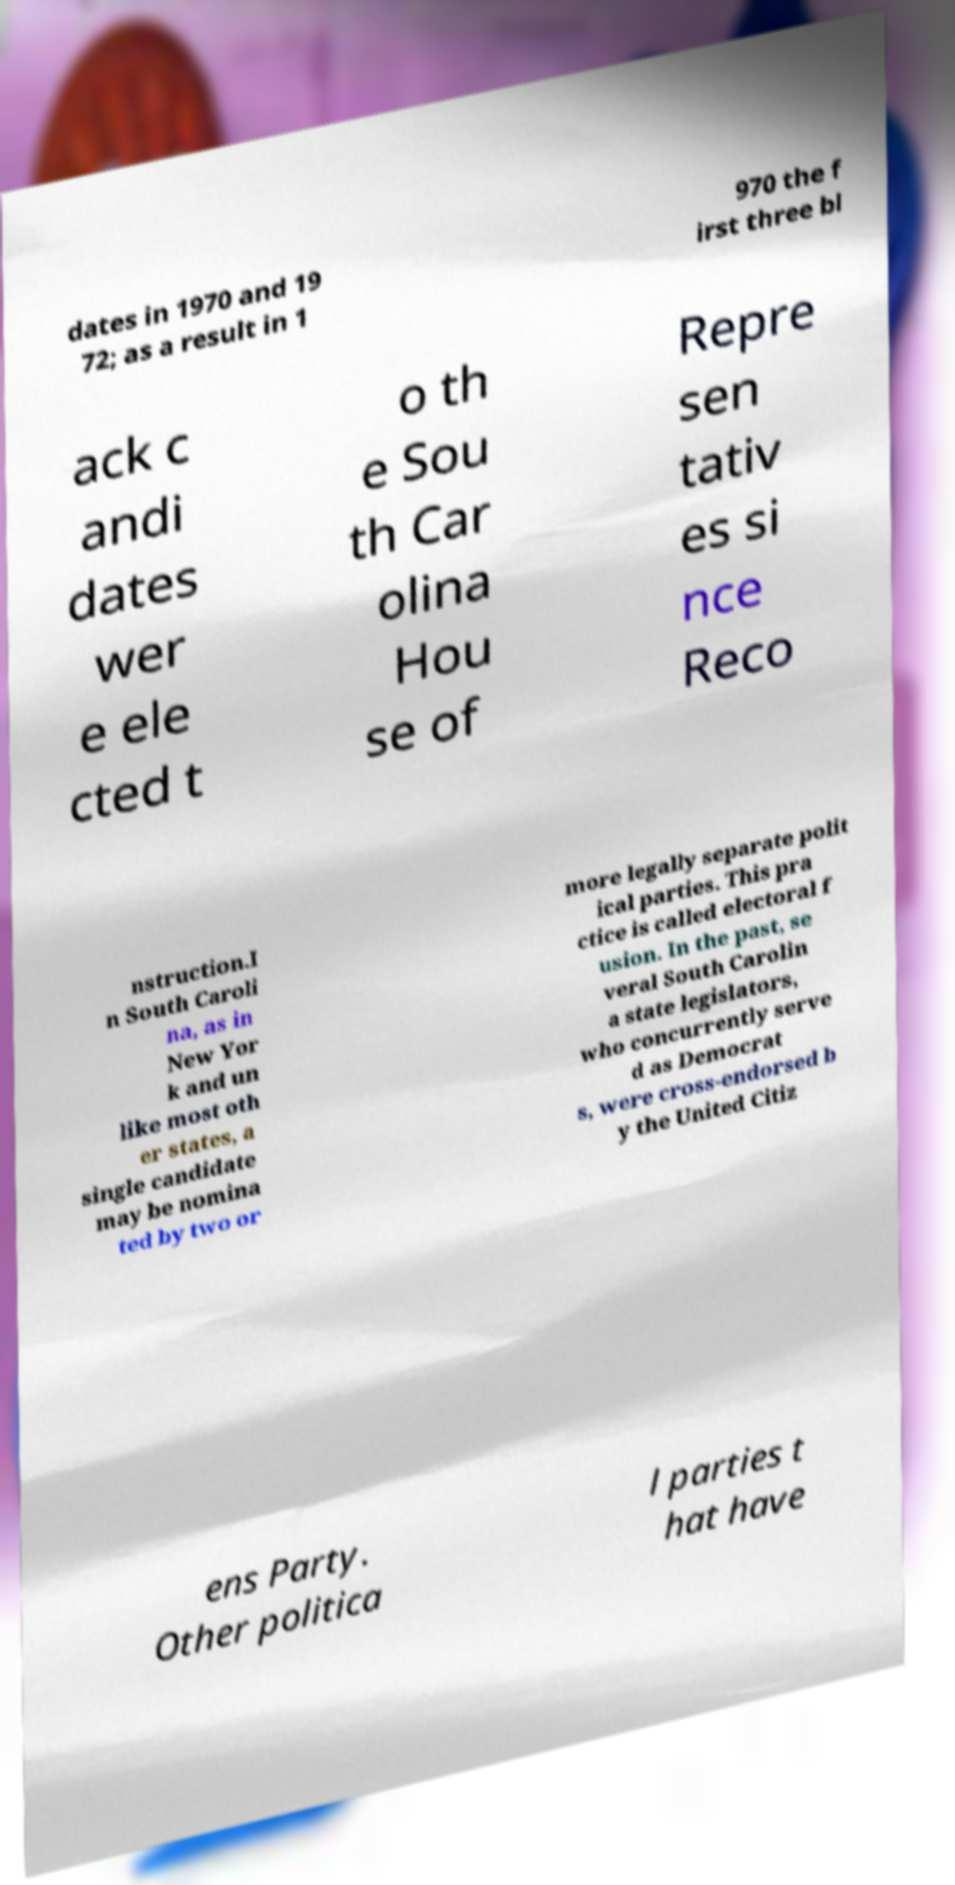Can you read and provide the text displayed in the image?This photo seems to have some interesting text. Can you extract and type it out for me? dates in 1970 and 19 72; as a result in 1 970 the f irst three bl ack c andi dates wer e ele cted t o th e Sou th Car olina Hou se of Repre sen tativ es si nce Reco nstruction.I n South Caroli na, as in New Yor k and un like most oth er states, a single candidate may be nomina ted by two or more legally separate polit ical parties. This pra ctice is called electoral f usion. In the past, se veral South Carolin a state legislators, who concurrently serve d as Democrat s, were cross-endorsed b y the United Citiz ens Party. Other politica l parties t hat have 